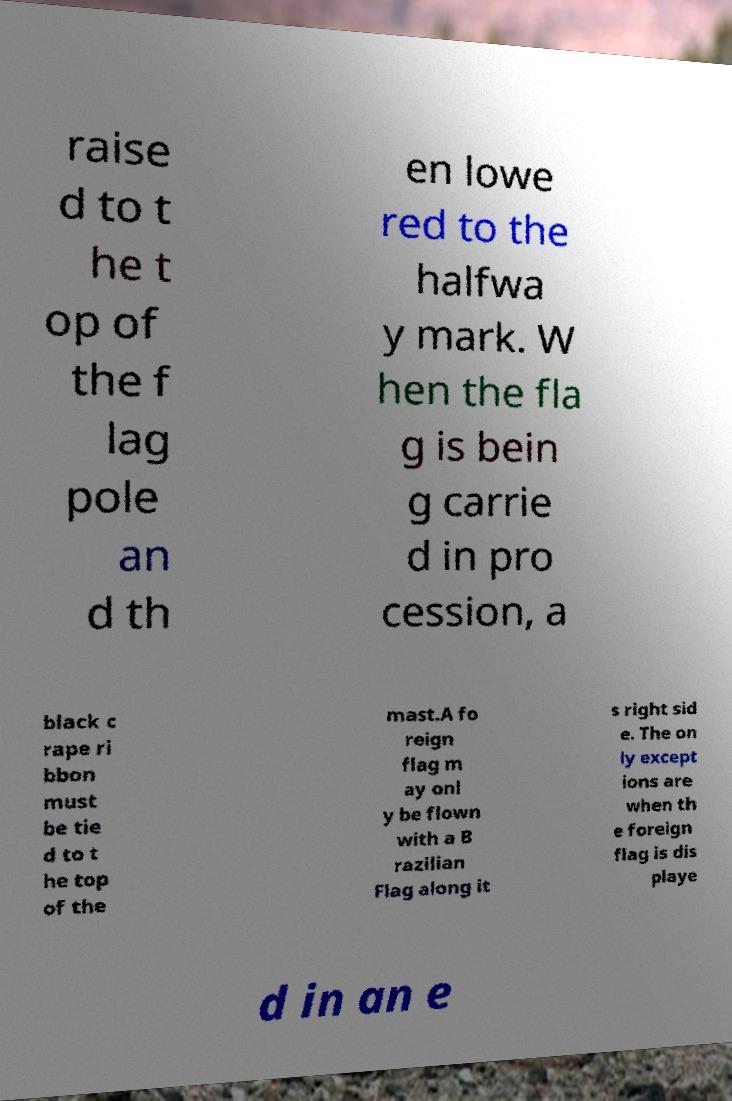Can you accurately transcribe the text from the provided image for me? raise d to t he t op of the f lag pole an d th en lowe red to the halfwa y mark. W hen the fla g is bein g carrie d in pro cession, a black c rape ri bbon must be tie d to t he top of the mast.A fo reign flag m ay onl y be flown with a B razilian Flag along it s right sid e. The on ly except ions are when th e foreign flag is dis playe d in an e 